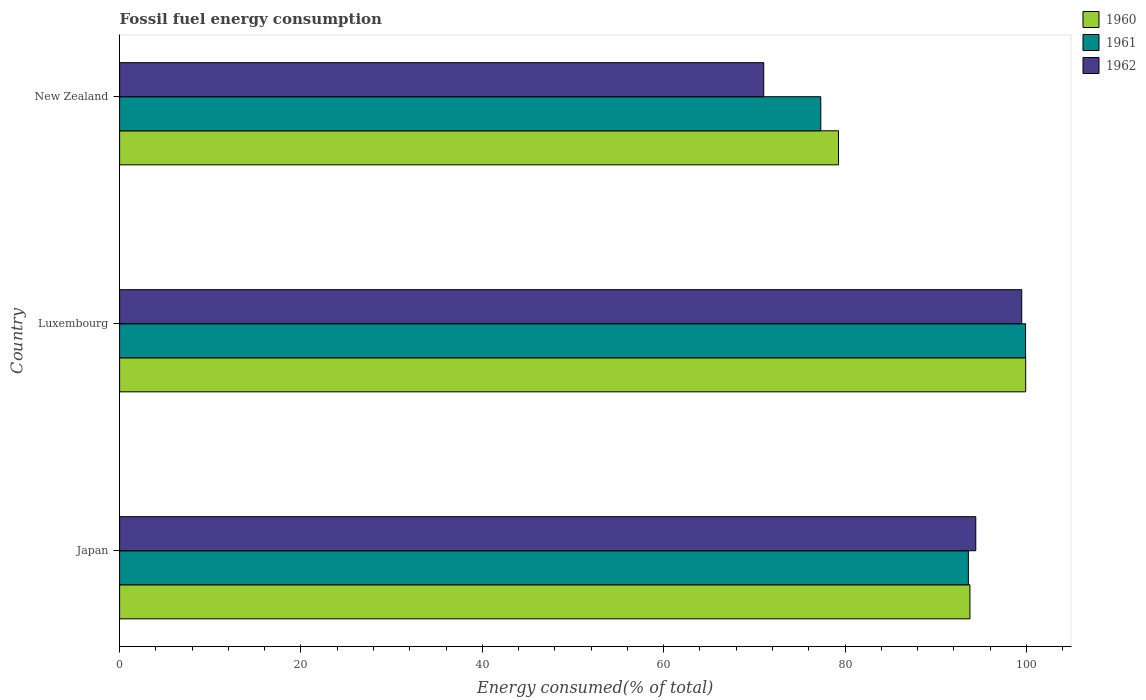Are the number of bars per tick equal to the number of legend labels?
Keep it short and to the point. Yes. How many bars are there on the 1st tick from the bottom?
Offer a terse response. 3. What is the label of the 1st group of bars from the top?
Your response must be concise. New Zealand. What is the percentage of energy consumed in 1960 in Japan?
Offer a terse response. 93.78. Across all countries, what is the maximum percentage of energy consumed in 1960?
Offer a terse response. 99.92. Across all countries, what is the minimum percentage of energy consumed in 1962?
Ensure brevity in your answer.  71.04. In which country was the percentage of energy consumed in 1961 maximum?
Offer a terse response. Luxembourg. In which country was the percentage of energy consumed in 1960 minimum?
Your answer should be compact. New Zealand. What is the total percentage of energy consumed in 1960 in the graph?
Keep it short and to the point. 272.98. What is the difference between the percentage of energy consumed in 1962 in Japan and that in New Zealand?
Your answer should be very brief. 23.38. What is the difference between the percentage of energy consumed in 1961 in New Zealand and the percentage of energy consumed in 1960 in Luxembourg?
Give a very brief answer. -22.6. What is the average percentage of energy consumed in 1961 per country?
Provide a short and direct response. 90.28. What is the difference between the percentage of energy consumed in 1962 and percentage of energy consumed in 1961 in Luxembourg?
Keep it short and to the point. -0.42. What is the ratio of the percentage of energy consumed in 1962 in Japan to that in New Zealand?
Your response must be concise. 1.33. What is the difference between the highest and the second highest percentage of energy consumed in 1961?
Give a very brief answer. 6.31. What is the difference between the highest and the lowest percentage of energy consumed in 1961?
Your answer should be compact. 22.58. Is the sum of the percentage of energy consumed in 1960 in Japan and New Zealand greater than the maximum percentage of energy consumed in 1962 across all countries?
Give a very brief answer. Yes. What does the 3rd bar from the top in Japan represents?
Ensure brevity in your answer.  1960. Are all the bars in the graph horizontal?
Your response must be concise. Yes. How many countries are there in the graph?
Your answer should be very brief. 3. What is the difference between two consecutive major ticks on the X-axis?
Provide a short and direct response. 20. Does the graph contain grids?
Ensure brevity in your answer.  No. Where does the legend appear in the graph?
Your answer should be compact. Top right. How many legend labels are there?
Keep it short and to the point. 3. What is the title of the graph?
Your answer should be very brief. Fossil fuel energy consumption. What is the label or title of the X-axis?
Offer a terse response. Energy consumed(% of total). What is the Energy consumed(% of total) of 1960 in Japan?
Give a very brief answer. 93.78. What is the Energy consumed(% of total) in 1961 in Japan?
Offer a very short reply. 93.6. What is the Energy consumed(% of total) in 1962 in Japan?
Offer a very short reply. 94.42. What is the Energy consumed(% of total) in 1960 in Luxembourg?
Make the answer very short. 99.92. What is the Energy consumed(% of total) of 1961 in Luxembourg?
Your answer should be very brief. 99.91. What is the Energy consumed(% of total) of 1962 in Luxembourg?
Your answer should be compact. 99.49. What is the Energy consumed(% of total) in 1960 in New Zealand?
Make the answer very short. 79.28. What is the Energy consumed(% of total) of 1961 in New Zealand?
Ensure brevity in your answer.  77.33. What is the Energy consumed(% of total) of 1962 in New Zealand?
Provide a succinct answer. 71.04. Across all countries, what is the maximum Energy consumed(% of total) in 1960?
Give a very brief answer. 99.92. Across all countries, what is the maximum Energy consumed(% of total) of 1961?
Offer a terse response. 99.91. Across all countries, what is the maximum Energy consumed(% of total) of 1962?
Give a very brief answer. 99.49. Across all countries, what is the minimum Energy consumed(% of total) in 1960?
Make the answer very short. 79.28. Across all countries, what is the minimum Energy consumed(% of total) of 1961?
Make the answer very short. 77.33. Across all countries, what is the minimum Energy consumed(% of total) in 1962?
Offer a very short reply. 71.04. What is the total Energy consumed(% of total) of 1960 in the graph?
Provide a short and direct response. 272.98. What is the total Energy consumed(% of total) in 1961 in the graph?
Offer a very short reply. 270.84. What is the total Energy consumed(% of total) in 1962 in the graph?
Keep it short and to the point. 264.94. What is the difference between the Energy consumed(% of total) of 1960 in Japan and that in Luxembourg?
Your answer should be very brief. -6.15. What is the difference between the Energy consumed(% of total) in 1961 in Japan and that in Luxembourg?
Offer a very short reply. -6.31. What is the difference between the Energy consumed(% of total) of 1962 in Japan and that in Luxembourg?
Ensure brevity in your answer.  -5.07. What is the difference between the Energy consumed(% of total) in 1960 in Japan and that in New Zealand?
Your response must be concise. 14.5. What is the difference between the Energy consumed(% of total) of 1961 in Japan and that in New Zealand?
Offer a very short reply. 16.28. What is the difference between the Energy consumed(% of total) in 1962 in Japan and that in New Zealand?
Your answer should be compact. 23.38. What is the difference between the Energy consumed(% of total) of 1960 in Luxembourg and that in New Zealand?
Offer a terse response. 20.65. What is the difference between the Energy consumed(% of total) in 1961 in Luxembourg and that in New Zealand?
Your answer should be very brief. 22.58. What is the difference between the Energy consumed(% of total) in 1962 in Luxembourg and that in New Zealand?
Ensure brevity in your answer.  28.45. What is the difference between the Energy consumed(% of total) of 1960 in Japan and the Energy consumed(% of total) of 1961 in Luxembourg?
Your answer should be very brief. -6.14. What is the difference between the Energy consumed(% of total) of 1960 in Japan and the Energy consumed(% of total) of 1962 in Luxembourg?
Ensure brevity in your answer.  -5.71. What is the difference between the Energy consumed(% of total) of 1961 in Japan and the Energy consumed(% of total) of 1962 in Luxembourg?
Offer a very short reply. -5.88. What is the difference between the Energy consumed(% of total) of 1960 in Japan and the Energy consumed(% of total) of 1961 in New Zealand?
Keep it short and to the point. 16.45. What is the difference between the Energy consumed(% of total) of 1960 in Japan and the Energy consumed(% of total) of 1962 in New Zealand?
Your answer should be very brief. 22.74. What is the difference between the Energy consumed(% of total) in 1961 in Japan and the Energy consumed(% of total) in 1962 in New Zealand?
Offer a terse response. 22.57. What is the difference between the Energy consumed(% of total) in 1960 in Luxembourg and the Energy consumed(% of total) in 1961 in New Zealand?
Your answer should be compact. 22.6. What is the difference between the Energy consumed(% of total) of 1960 in Luxembourg and the Energy consumed(% of total) of 1962 in New Zealand?
Your answer should be very brief. 28.89. What is the difference between the Energy consumed(% of total) in 1961 in Luxembourg and the Energy consumed(% of total) in 1962 in New Zealand?
Your answer should be very brief. 28.88. What is the average Energy consumed(% of total) in 1960 per country?
Your answer should be very brief. 90.99. What is the average Energy consumed(% of total) in 1961 per country?
Keep it short and to the point. 90.28. What is the average Energy consumed(% of total) in 1962 per country?
Ensure brevity in your answer.  88.31. What is the difference between the Energy consumed(% of total) in 1960 and Energy consumed(% of total) in 1961 in Japan?
Keep it short and to the point. 0.17. What is the difference between the Energy consumed(% of total) in 1960 and Energy consumed(% of total) in 1962 in Japan?
Your answer should be very brief. -0.64. What is the difference between the Energy consumed(% of total) in 1961 and Energy consumed(% of total) in 1962 in Japan?
Offer a very short reply. -0.82. What is the difference between the Energy consumed(% of total) in 1960 and Energy consumed(% of total) in 1961 in Luxembourg?
Provide a succinct answer. 0.01. What is the difference between the Energy consumed(% of total) in 1960 and Energy consumed(% of total) in 1962 in Luxembourg?
Provide a succinct answer. 0.44. What is the difference between the Energy consumed(% of total) in 1961 and Energy consumed(% of total) in 1962 in Luxembourg?
Make the answer very short. 0.42. What is the difference between the Energy consumed(% of total) of 1960 and Energy consumed(% of total) of 1961 in New Zealand?
Your answer should be compact. 1.95. What is the difference between the Energy consumed(% of total) in 1960 and Energy consumed(% of total) in 1962 in New Zealand?
Offer a very short reply. 8.24. What is the difference between the Energy consumed(% of total) of 1961 and Energy consumed(% of total) of 1962 in New Zealand?
Your answer should be very brief. 6.29. What is the ratio of the Energy consumed(% of total) of 1960 in Japan to that in Luxembourg?
Your answer should be very brief. 0.94. What is the ratio of the Energy consumed(% of total) in 1961 in Japan to that in Luxembourg?
Offer a terse response. 0.94. What is the ratio of the Energy consumed(% of total) in 1962 in Japan to that in Luxembourg?
Your response must be concise. 0.95. What is the ratio of the Energy consumed(% of total) of 1960 in Japan to that in New Zealand?
Provide a succinct answer. 1.18. What is the ratio of the Energy consumed(% of total) in 1961 in Japan to that in New Zealand?
Ensure brevity in your answer.  1.21. What is the ratio of the Energy consumed(% of total) in 1962 in Japan to that in New Zealand?
Offer a terse response. 1.33. What is the ratio of the Energy consumed(% of total) of 1960 in Luxembourg to that in New Zealand?
Your answer should be very brief. 1.26. What is the ratio of the Energy consumed(% of total) of 1961 in Luxembourg to that in New Zealand?
Give a very brief answer. 1.29. What is the ratio of the Energy consumed(% of total) in 1962 in Luxembourg to that in New Zealand?
Offer a very short reply. 1.4. What is the difference between the highest and the second highest Energy consumed(% of total) of 1960?
Your answer should be very brief. 6.15. What is the difference between the highest and the second highest Energy consumed(% of total) in 1961?
Your answer should be compact. 6.31. What is the difference between the highest and the second highest Energy consumed(% of total) of 1962?
Ensure brevity in your answer.  5.07. What is the difference between the highest and the lowest Energy consumed(% of total) in 1960?
Make the answer very short. 20.65. What is the difference between the highest and the lowest Energy consumed(% of total) of 1961?
Offer a very short reply. 22.58. What is the difference between the highest and the lowest Energy consumed(% of total) in 1962?
Your answer should be very brief. 28.45. 